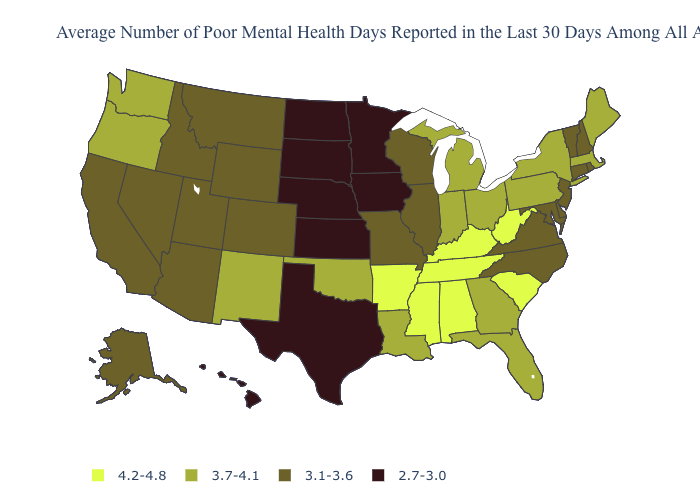What is the value of Illinois?
Quick response, please. 3.1-3.6. Does the map have missing data?
Answer briefly. No. Name the states that have a value in the range 2.7-3.0?
Give a very brief answer. Hawaii, Iowa, Kansas, Minnesota, Nebraska, North Dakota, South Dakota, Texas. What is the highest value in states that border Maryland?
Give a very brief answer. 4.2-4.8. Name the states that have a value in the range 3.7-4.1?
Quick response, please. Florida, Georgia, Indiana, Louisiana, Maine, Massachusetts, Michigan, New Mexico, New York, Ohio, Oklahoma, Oregon, Pennsylvania, Washington. Name the states that have a value in the range 3.1-3.6?
Be succinct. Alaska, Arizona, California, Colorado, Connecticut, Delaware, Idaho, Illinois, Maryland, Missouri, Montana, Nevada, New Hampshire, New Jersey, North Carolina, Rhode Island, Utah, Vermont, Virginia, Wisconsin, Wyoming. Name the states that have a value in the range 4.2-4.8?
Write a very short answer. Alabama, Arkansas, Kentucky, Mississippi, South Carolina, Tennessee, West Virginia. What is the value of Kansas?
Be succinct. 2.7-3.0. What is the value of Montana?
Be succinct. 3.1-3.6. What is the value of West Virginia?
Be succinct. 4.2-4.8. Name the states that have a value in the range 3.1-3.6?
Short answer required. Alaska, Arizona, California, Colorado, Connecticut, Delaware, Idaho, Illinois, Maryland, Missouri, Montana, Nevada, New Hampshire, New Jersey, North Carolina, Rhode Island, Utah, Vermont, Virginia, Wisconsin, Wyoming. Name the states that have a value in the range 4.2-4.8?
Concise answer only. Alabama, Arkansas, Kentucky, Mississippi, South Carolina, Tennessee, West Virginia. Name the states that have a value in the range 2.7-3.0?
Quick response, please. Hawaii, Iowa, Kansas, Minnesota, Nebraska, North Dakota, South Dakota, Texas. What is the highest value in states that border Kansas?
Give a very brief answer. 3.7-4.1. What is the value of Texas?
Short answer required. 2.7-3.0. 